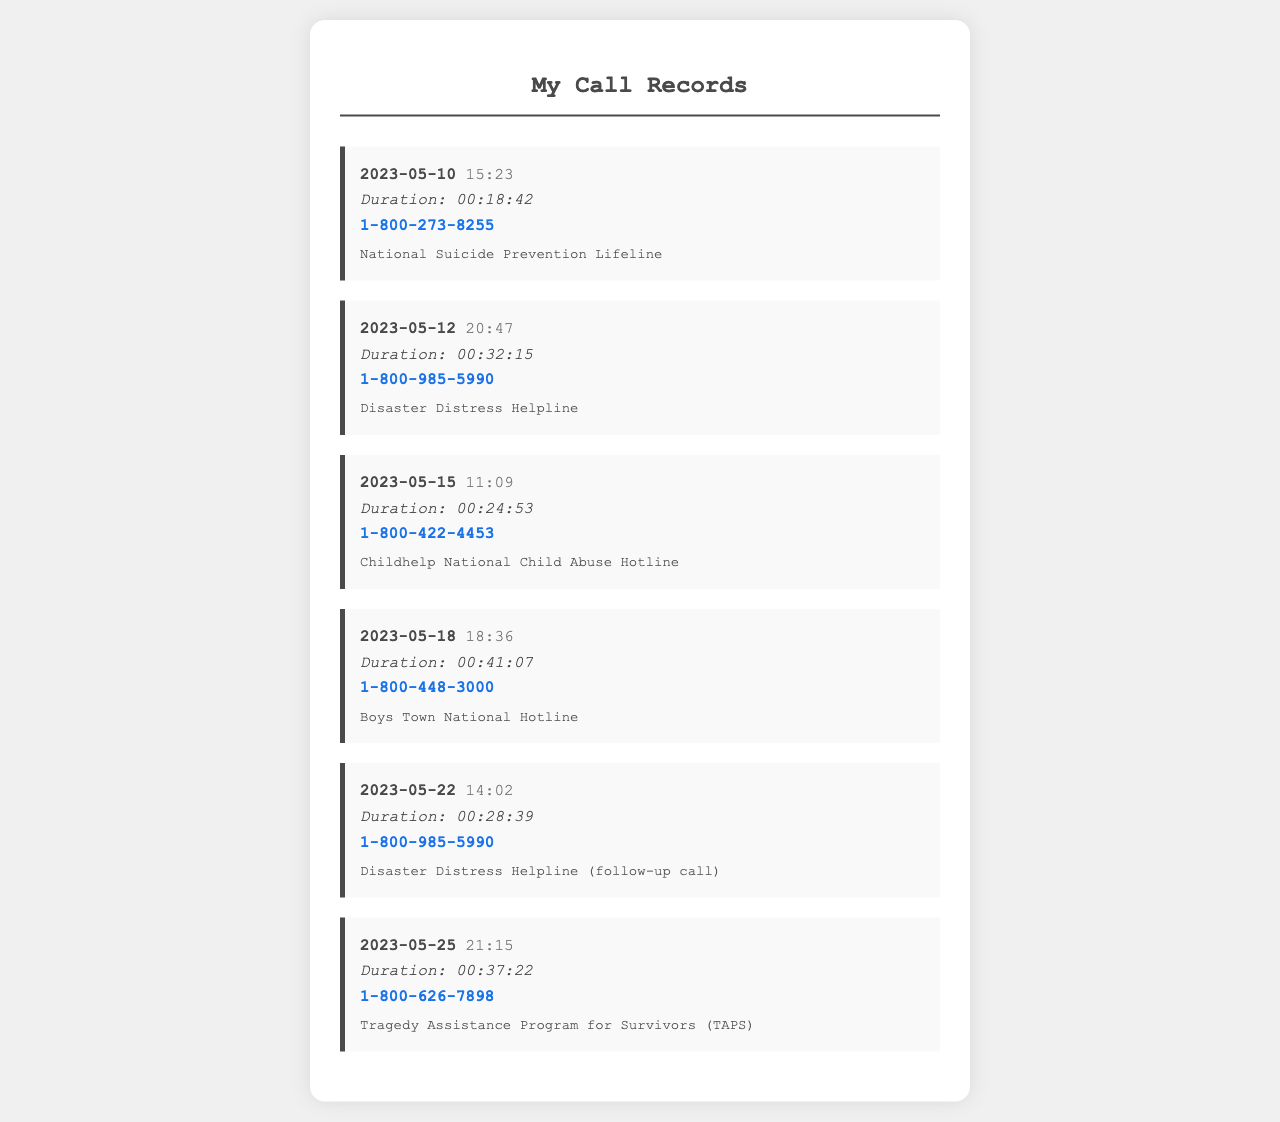what is the date of the first call? The first call is listed on May 10, 2023.
Answer: May 10, 2023 what is the duration of the longest call? The longest call, on May 18, 2023, has a duration of 41 minutes and 7 seconds.
Answer: 00:41:07 how many times was the Disaster Distress Helpline called? The Disaster Distress Helpline was called twice, on May 12 and May 22, 2023.
Answer: 2 what is the phone number for the National Suicide Prevention Lifeline? The phone number for the National Suicide Prevention Lifeline is shown in the first call record.
Answer: 1-800-273-8255 which hotline was called on May 15, 2023? The call on May 15, 2023, was made to the Childhelp National Child Abuse Hotline.
Answer: Childhelp National Child Abuse Hotline how long was the call made on May 22, 2023? The call made on May 22, 2023, lasted for 28 minutes and 39 seconds.
Answer: 00:28:39 which hotline has the call description "follow-up call"? The follow-up call description is associated with the Disaster Distress Helpline on May 22, 2023.
Answer: Disaster Distress Helpline what is the time of the call made on May 25, 2023? The call on May 25, 2023, was made at 21:15.
Answer: 21:15 what hotline is associated with the number 1-800-626-7898? The phone number 1-800-626-7898 is associated with the Tragedy Assistance Program for Survivors (TAPS).
Answer: Tragedy Assistance Program for Survivors (TAPS) 